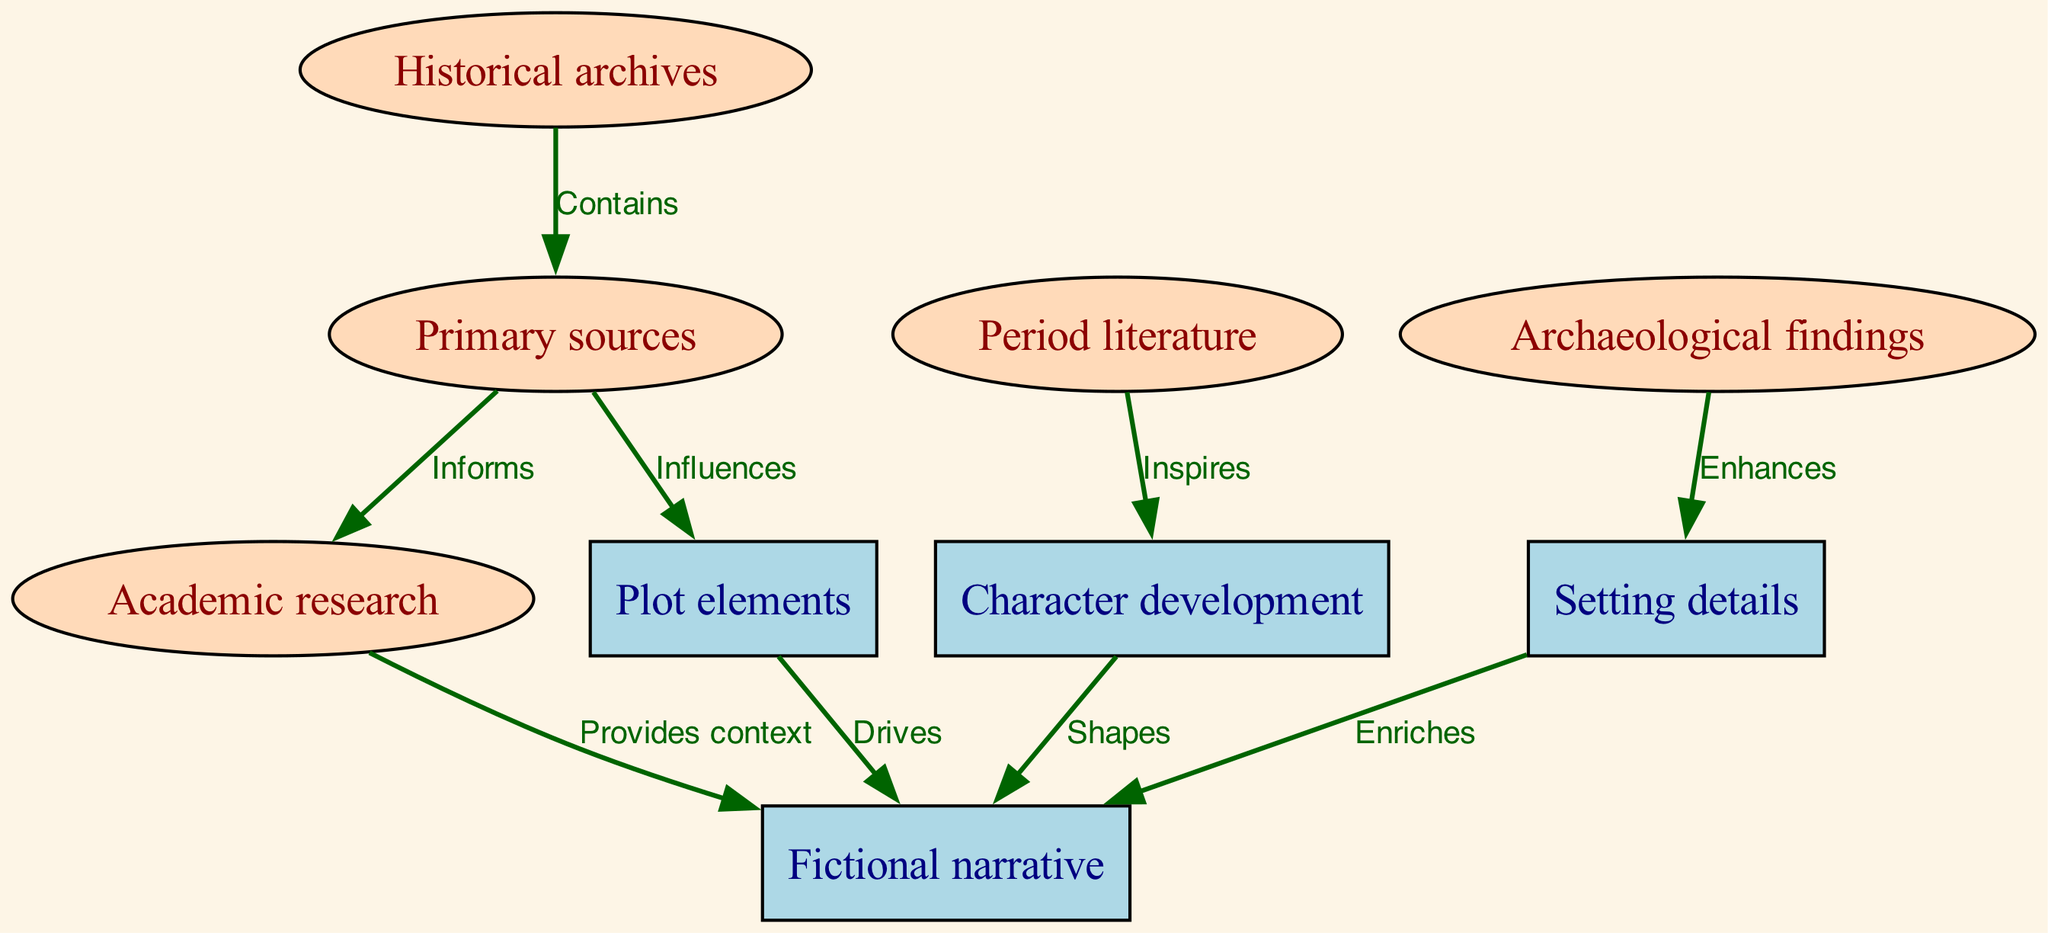What are the total number of nodes in the diagram? The diagram lists eight distinct nodes: Historical archives, Primary sources, Academic research, Period literature, Archaeological findings, Fictional narrative, Character development, Plot elements, and Setting details. Thus, 8 nodes total.
Answer: 8 Which source enhances setting details? The directed edge from Archaeological findings points to Setting details with the label "Enhances." Hence, Archaeological findings is the source.
Answer: Archaeological findings What type of relationship exists between Primary sources and Academic research? The edge from Primary sources to Academic research indicates that the relationship is one where Primary sources "Informs" Academic research. Thus, the relationship is informing.
Answer: Informs How many edges are connected to the Fictional narrative? The diagram shows three edges connected to Fictional narrative: from Academic research, Character development, and Plot elements. Therefore, there are three edges.
Answer: 3 Which node is influenced by Primary sources? According to the diagram, Primary sources points to Plot elements, showing that it influences Plot elements. Therefore, Plot elements is the influenced node.
Answer: Plot elements What do character development and plot elements drive? The edges show that Character development and Plot elements both point to Fictional narrative. Since both drive, they contribute to shaping the Fictional narrative.
Answer: Fictional narrative Identify one type of source that provides context for the fictional narrative. The diagram indicates an edge from Academic research to Fictional narrative labeled "Provides context," making Academic research a source that provides context for the narrative.
Answer: Academic research How does period literature contribute to character development? The diagram illustrates that Period literature inspires Character development, indicating a direct connection where one influences the other through inspiration.
Answer: Inspires What shapes the fictional narrative? The directed edge from Character development to Fictional narrative shows that Character development shapes the narrative, indicating its impact on the overall story structure.
Answer: Character development 